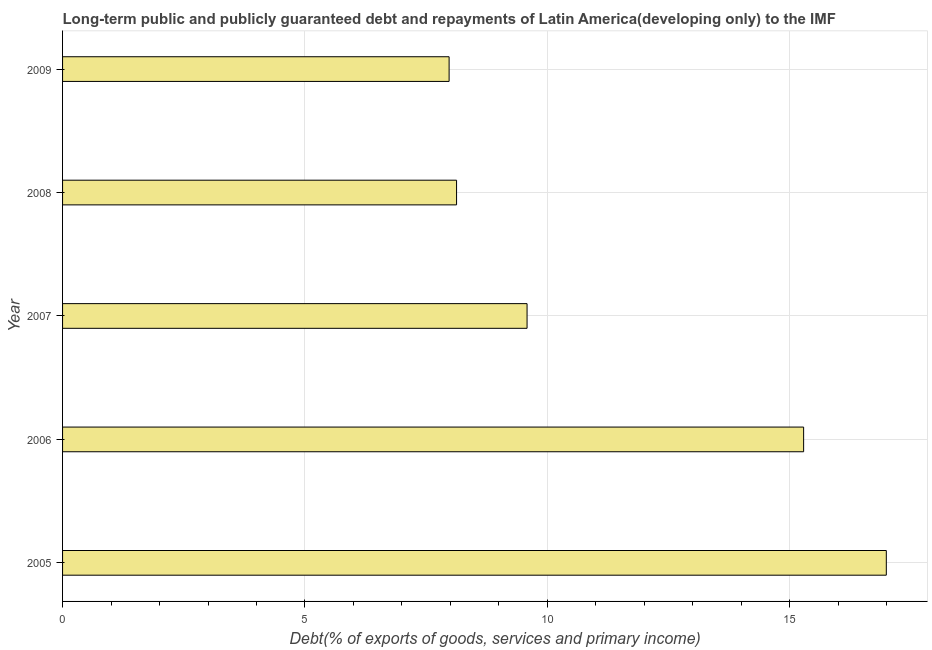Does the graph contain grids?
Make the answer very short. Yes. What is the title of the graph?
Your answer should be compact. Long-term public and publicly guaranteed debt and repayments of Latin America(developing only) to the IMF. What is the label or title of the X-axis?
Offer a terse response. Debt(% of exports of goods, services and primary income). What is the label or title of the Y-axis?
Give a very brief answer. Year. What is the debt service in 2005?
Your answer should be compact. 16.99. Across all years, what is the maximum debt service?
Offer a terse response. 16.99. Across all years, what is the minimum debt service?
Your answer should be very brief. 7.97. In which year was the debt service minimum?
Keep it short and to the point. 2009. What is the sum of the debt service?
Provide a succinct answer. 57.96. What is the difference between the debt service in 2005 and 2008?
Give a very brief answer. 8.87. What is the average debt service per year?
Your answer should be compact. 11.59. What is the median debt service?
Provide a short and direct response. 9.58. Do a majority of the years between 2008 and 2009 (inclusive) have debt service greater than 10 %?
Provide a succinct answer. No. What is the ratio of the debt service in 2008 to that in 2009?
Offer a very short reply. 1.02. Is the difference between the debt service in 2006 and 2007 greater than the difference between any two years?
Provide a short and direct response. No. What is the difference between the highest and the second highest debt service?
Offer a terse response. 1.71. Is the sum of the debt service in 2006 and 2009 greater than the maximum debt service across all years?
Give a very brief answer. Yes. What is the difference between the highest and the lowest debt service?
Ensure brevity in your answer.  9.02. In how many years, is the debt service greater than the average debt service taken over all years?
Offer a terse response. 2. What is the difference between two consecutive major ticks on the X-axis?
Make the answer very short. 5. What is the Debt(% of exports of goods, services and primary income) in 2005?
Provide a short and direct response. 16.99. What is the Debt(% of exports of goods, services and primary income) in 2006?
Provide a succinct answer. 15.29. What is the Debt(% of exports of goods, services and primary income) in 2007?
Make the answer very short. 9.58. What is the Debt(% of exports of goods, services and primary income) of 2008?
Your answer should be compact. 8.13. What is the Debt(% of exports of goods, services and primary income) in 2009?
Your answer should be compact. 7.97. What is the difference between the Debt(% of exports of goods, services and primary income) in 2005 and 2006?
Provide a short and direct response. 1.71. What is the difference between the Debt(% of exports of goods, services and primary income) in 2005 and 2007?
Your response must be concise. 7.41. What is the difference between the Debt(% of exports of goods, services and primary income) in 2005 and 2008?
Keep it short and to the point. 8.86. What is the difference between the Debt(% of exports of goods, services and primary income) in 2005 and 2009?
Your answer should be very brief. 9.02. What is the difference between the Debt(% of exports of goods, services and primary income) in 2006 and 2007?
Keep it short and to the point. 5.71. What is the difference between the Debt(% of exports of goods, services and primary income) in 2006 and 2008?
Keep it short and to the point. 7.16. What is the difference between the Debt(% of exports of goods, services and primary income) in 2006 and 2009?
Ensure brevity in your answer.  7.31. What is the difference between the Debt(% of exports of goods, services and primary income) in 2007 and 2008?
Ensure brevity in your answer.  1.45. What is the difference between the Debt(% of exports of goods, services and primary income) in 2007 and 2009?
Offer a terse response. 1.61. What is the difference between the Debt(% of exports of goods, services and primary income) in 2008 and 2009?
Your response must be concise. 0.15. What is the ratio of the Debt(% of exports of goods, services and primary income) in 2005 to that in 2006?
Ensure brevity in your answer.  1.11. What is the ratio of the Debt(% of exports of goods, services and primary income) in 2005 to that in 2007?
Your answer should be compact. 1.77. What is the ratio of the Debt(% of exports of goods, services and primary income) in 2005 to that in 2008?
Give a very brief answer. 2.09. What is the ratio of the Debt(% of exports of goods, services and primary income) in 2005 to that in 2009?
Provide a short and direct response. 2.13. What is the ratio of the Debt(% of exports of goods, services and primary income) in 2006 to that in 2007?
Make the answer very short. 1.59. What is the ratio of the Debt(% of exports of goods, services and primary income) in 2006 to that in 2008?
Provide a succinct answer. 1.88. What is the ratio of the Debt(% of exports of goods, services and primary income) in 2006 to that in 2009?
Offer a terse response. 1.92. What is the ratio of the Debt(% of exports of goods, services and primary income) in 2007 to that in 2008?
Your answer should be compact. 1.18. What is the ratio of the Debt(% of exports of goods, services and primary income) in 2007 to that in 2009?
Your answer should be very brief. 1.2. What is the ratio of the Debt(% of exports of goods, services and primary income) in 2008 to that in 2009?
Your answer should be very brief. 1.02. 